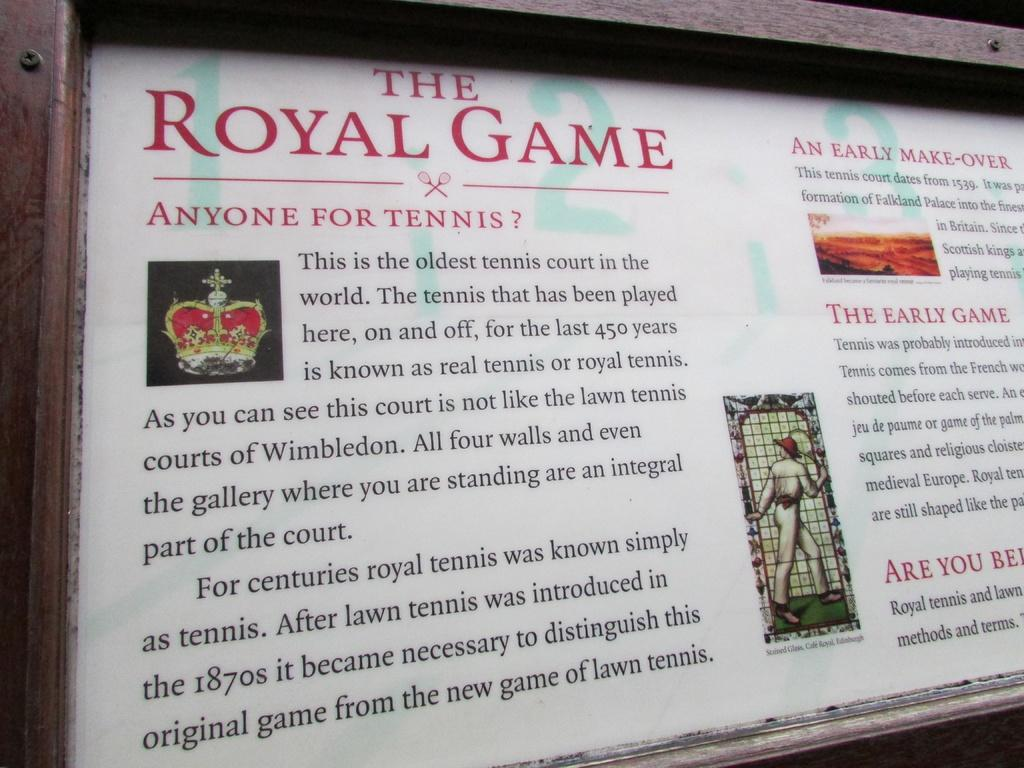<image>
Write a terse but informative summary of the picture. An article discusses the differences between royal tennis and lawn tennis. 